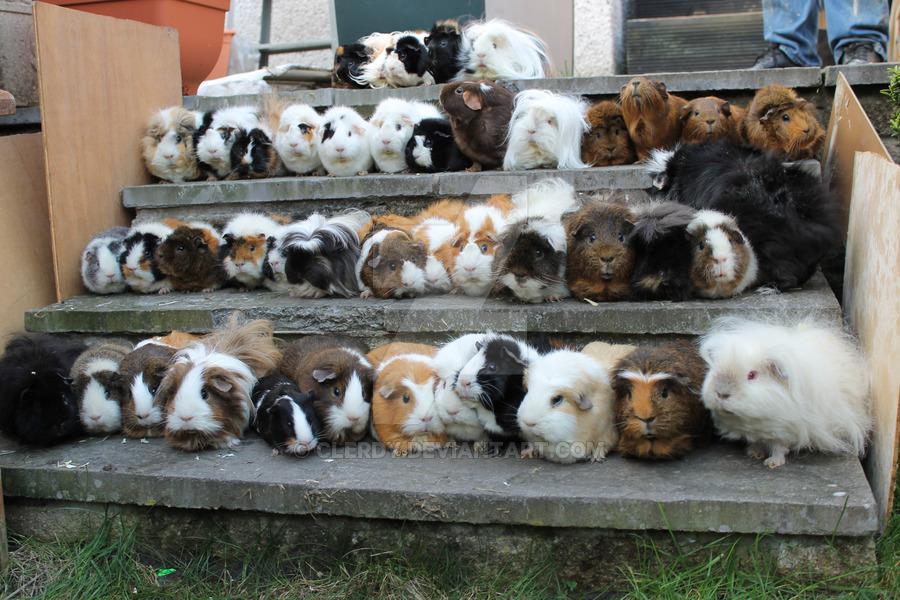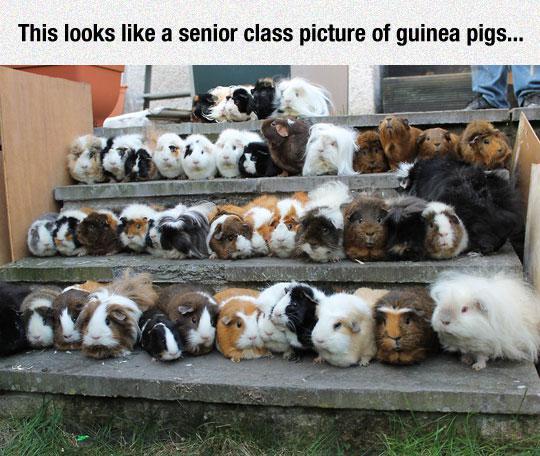The first image is the image on the left, the second image is the image on the right. Considering the images on both sides, is "At least one image shows guinea pigs lined up on three steps." valid? Answer yes or no. Yes. 